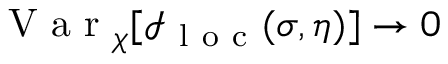<formula> <loc_0><loc_0><loc_500><loc_500>V a r _ { \chi } [ \mathcal { I } _ { l o c } ( \sigma , \eta ) ] \rightarrow 0</formula> 